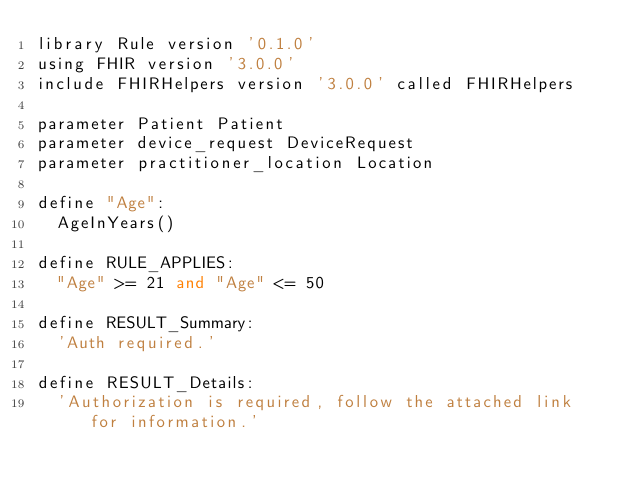Convert code to text. <code><loc_0><loc_0><loc_500><loc_500><_SQL_>library Rule version '0.1.0'
using FHIR version '3.0.0'
include FHIRHelpers version '3.0.0' called FHIRHelpers

parameter Patient Patient
parameter device_request DeviceRequest
parameter practitioner_location Location

define "Age":
  AgeInYears()

define RULE_APPLIES:
  "Age" >= 21 and "Age" <= 50

define RESULT_Summary:
  'Auth required.'

define RESULT_Details:
  'Authorization is required, follow the attached link for information.'
</code> 